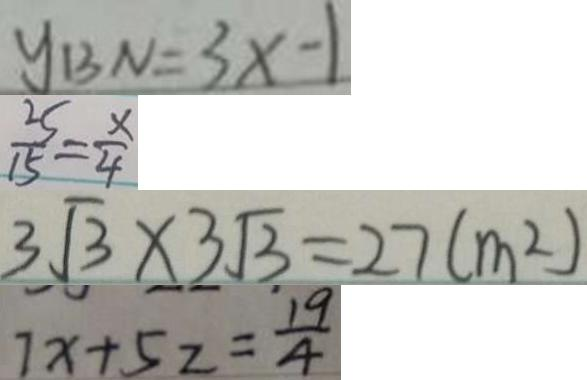<formula> <loc_0><loc_0><loc_500><loc_500>y _ { B N } = 3 x - 1 
 \frac { 2 5 } { 1 5 } = \frac { x } { 4 } 
 3 \sqrt { 3 } \times 3 \sqrt { 3 } = 2 7 ( m ^ { 2 } ) 
 7 x + 5 z = \frac { 1 9 } { 4 }</formula> 